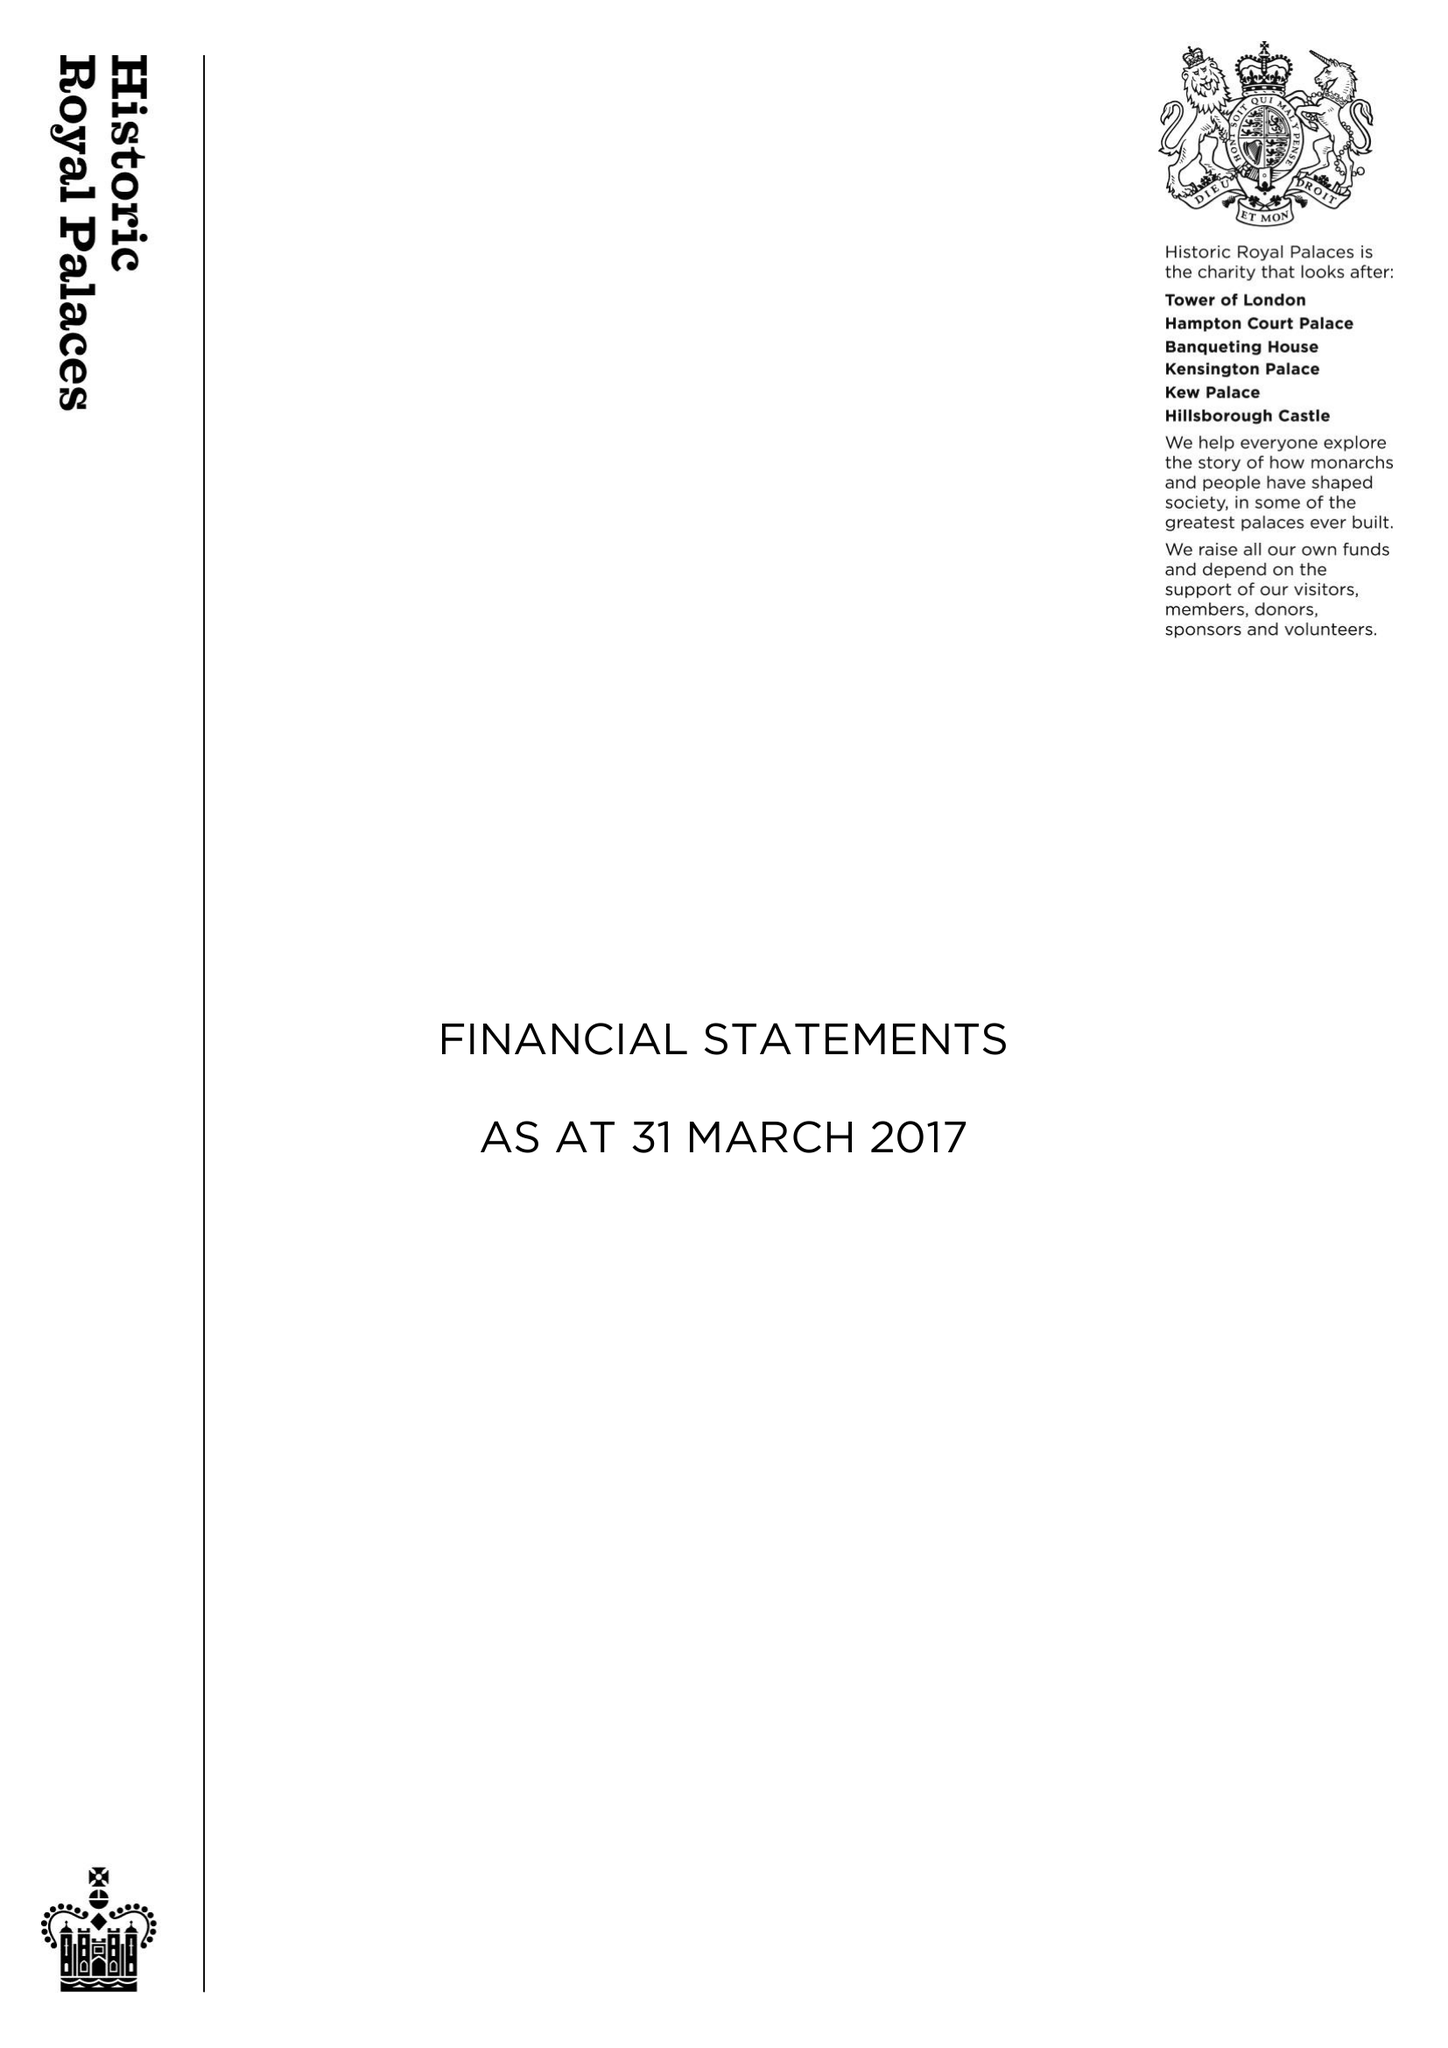What is the value for the address__postcode?
Answer the question using a single word or phrase. KT8 9AU 